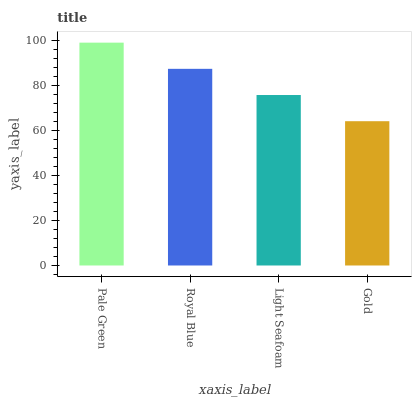Is Gold the minimum?
Answer yes or no. Yes. Is Pale Green the maximum?
Answer yes or no. Yes. Is Royal Blue the minimum?
Answer yes or no. No. Is Royal Blue the maximum?
Answer yes or no. No. Is Pale Green greater than Royal Blue?
Answer yes or no. Yes. Is Royal Blue less than Pale Green?
Answer yes or no. Yes. Is Royal Blue greater than Pale Green?
Answer yes or no. No. Is Pale Green less than Royal Blue?
Answer yes or no. No. Is Royal Blue the high median?
Answer yes or no. Yes. Is Light Seafoam the low median?
Answer yes or no. Yes. Is Pale Green the high median?
Answer yes or no. No. Is Gold the low median?
Answer yes or no. No. 